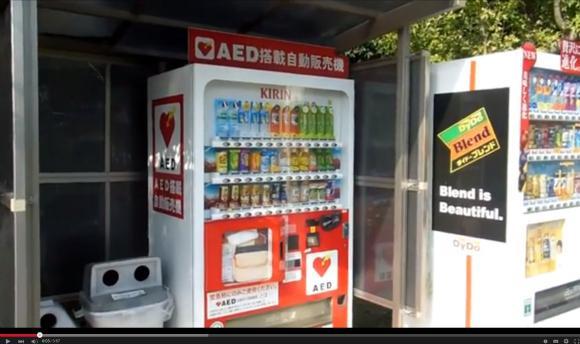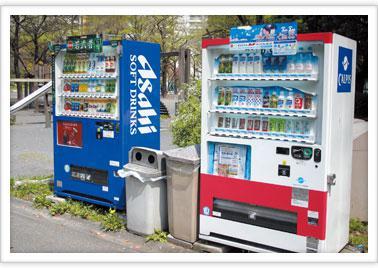The first image is the image on the left, the second image is the image on the right. Considering the images on both sides, is "Each image has two or fewer vending machines." valid? Answer yes or no. Yes. The first image is the image on the left, the second image is the image on the right. Analyze the images presented: Is the assertion "At least one of the images in each set contains only one vending machine." valid? Answer yes or no. No. 